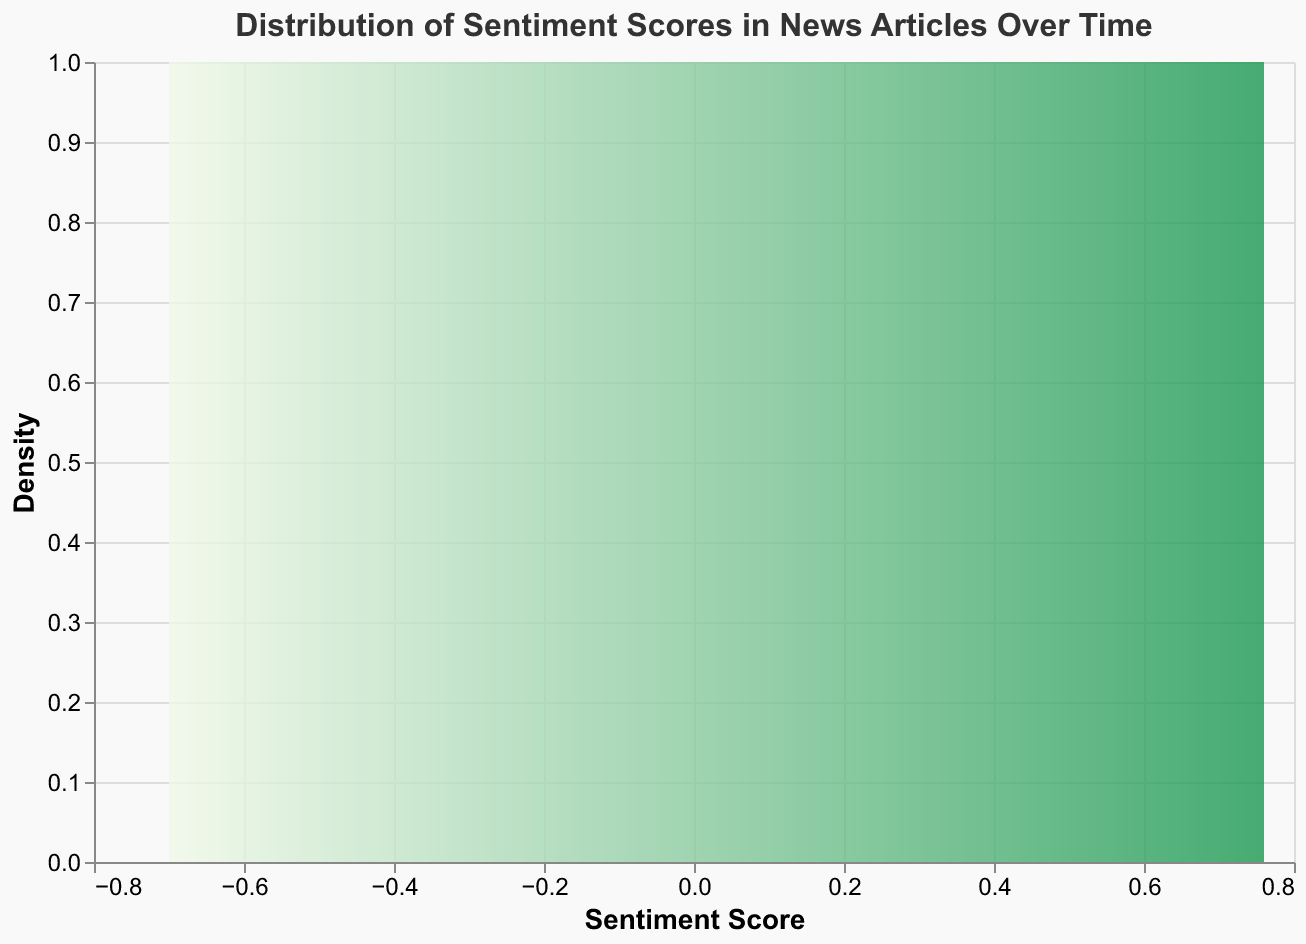What is the title of the figure? The title is located at the top of the figure. It reads "Distribution of Sentiment Scores in News Articles Over Time."
Answer: Distribution of Sentiment Scores in News Articles Over Time What is the range of the Sentiment Score axis? The Sentiment Score axis, which is the x-axis, ranges from approximately -0.7 to 0.76.
Answer: -0.7 to 0.76 Which sentiment score is the highest? The figure shows that the highest sentiment score on the x-axis is 0.76. This happens at the peak density representing this sentiment score.
Answer: 0.76 How many sentiment scores are greater than 0? The sentiment scores greater than 0 are 0.76 (CNN), 0.23 (Reuters), 0.05 (FoxNews), 0.60 (NewYorkTimes), 0.50 (TheGuardian), 0.73 (NBCNews), 0.15 (CBSNews), 0.42 (ABCNews), 0.35 (Bloomberg), 0.48 (EconTimes), and 0.20 (BusinessInsider), making a total of 11 data points.
Answer: 11 What is the most frequent sentiment score range shown on the density plot? The density plot shows higher densities around sentiment scores between 0.2 and 0.6.
Answer: 0.2 to 0.6 How does the color gradient change across the plot? The color gradient on the density plot transitions from light green (#f0f9e8) at lower densities to dark green (#1a9850) at higher densities.
Answer: From light green to dark green Is there a negative sentiment score with high density? The density plot shows notable density in the positive sentiment scores from 0.2 to 0.6, while negative sentiment scores show lower density.
Answer: No Which data point has the lowest sentiment score? The data point with the source "Forbes" has the lowest sentiment score as visible on the plot, which is -0.70.
Answer: -0.70 What is the average sentiment score for the negative sentiment scores? The negative sentiment scores are -0.45 (BBC), -0.32 (WashingtonPost), -0.15 (AlJazeera), -0.70 (Forbes), -0.65 (TheIntercept), -0.05 (WallStreetJournal). The average is calculated as (-0.45 - 0.32 - 0.15 - 0.70 - 0.65 - 0.05)/6 = -2.32/6 = -0.387.
Answer: -0.387 